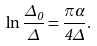<formula> <loc_0><loc_0><loc_500><loc_500>\ln \frac { \Delta _ { 0 } } \Delta = \frac { \pi \alpha } { 4 \Delta } .</formula> 